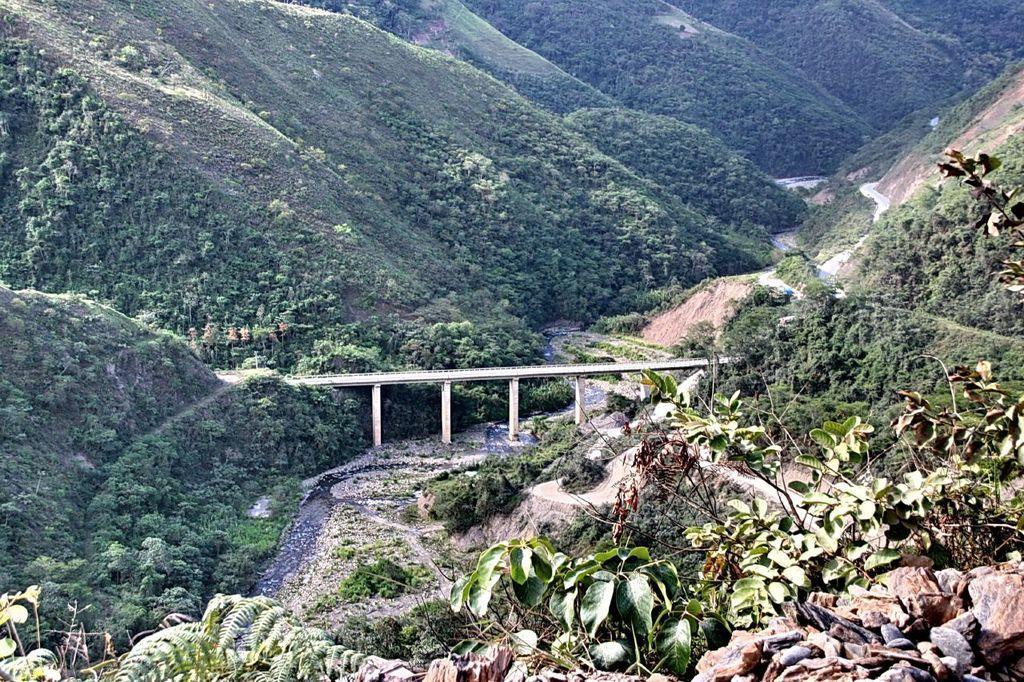How would you summarize this image in a sentence or two? In this image in the center there is one bridge, and on the right side and left side there are some mountains and trees. 